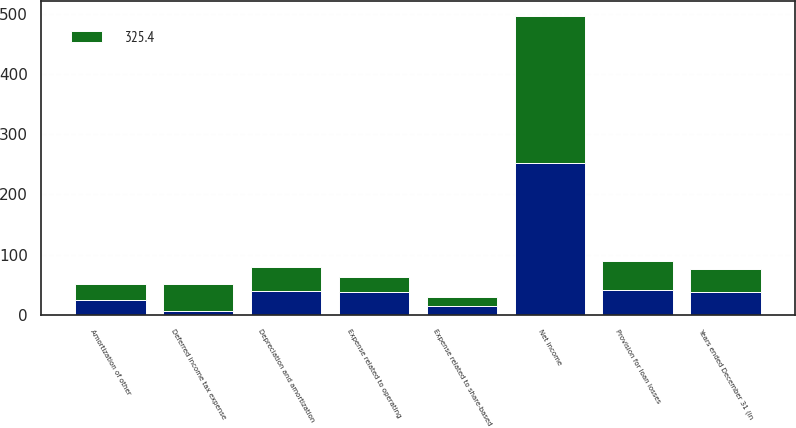Convert chart. <chart><loc_0><loc_0><loc_500><loc_500><stacked_bar_chart><ecel><fcel>Years ended December 31 (in<fcel>Net income<fcel>Provision for loan losses<fcel>Depreciation and amortization<fcel>Expense related to operating<fcel>Amortization of other<fcel>Deferred income tax expense<fcel>Expense related to share-based<nl><fcel>nan<fcel>38.25<fcel>251.7<fcel>40.6<fcel>39.6<fcel>37.4<fcel>24.8<fcel>6.7<fcel>14.9<nl><fcel>325.4<fcel>38.25<fcel>245.3<fcel>49.2<fcel>39.1<fcel>26.3<fcel>26.8<fcel>44.8<fcel>15.1<nl></chart> 